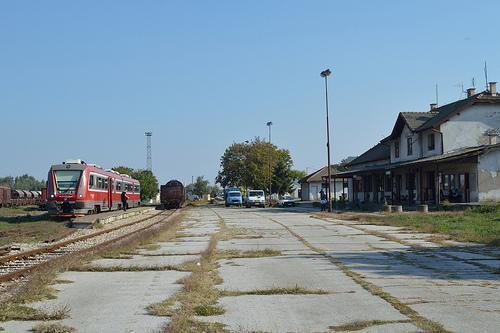How many visible cell towers?
Give a very brief answer. 1. How many chimneys are visible?
Give a very brief answer. 3. 